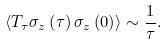Convert formula to latex. <formula><loc_0><loc_0><loc_500><loc_500>\left < T _ { \tau } \sigma _ { z } \left ( \tau \right ) \sigma _ { z } \left ( 0 \right ) \right > \sim \frac { 1 } { \tau } .</formula> 